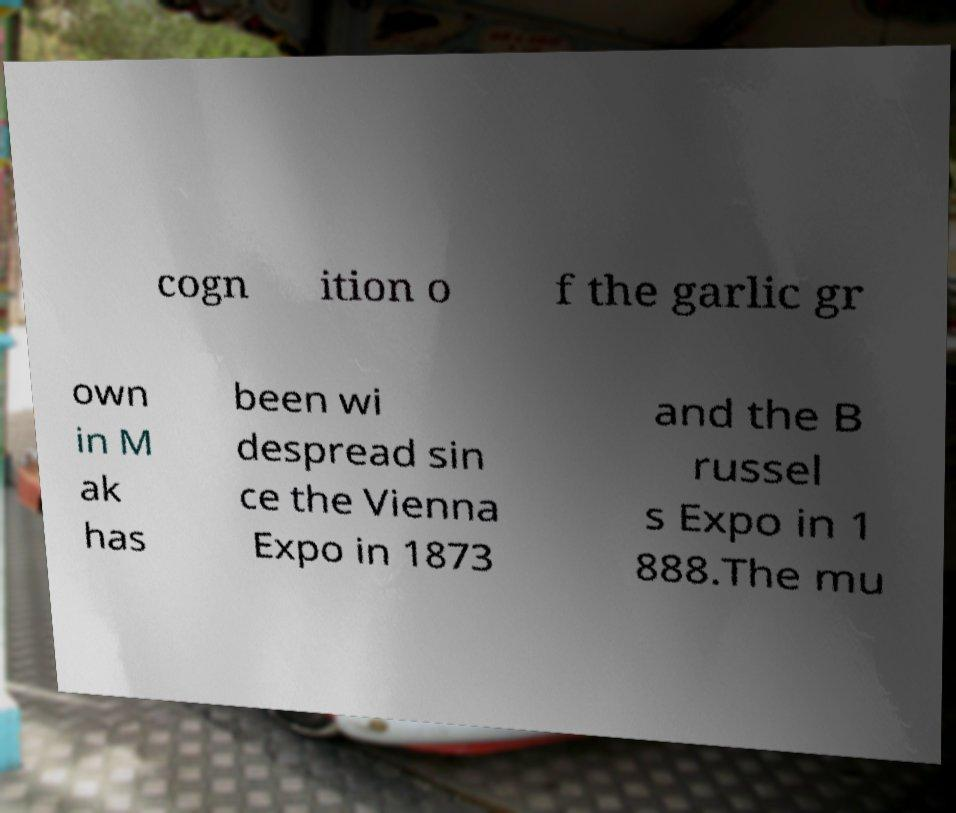There's text embedded in this image that I need extracted. Can you transcribe it verbatim? cogn ition o f the garlic gr own in M ak has been wi despread sin ce the Vienna Expo in 1873 and the B russel s Expo in 1 888.The mu 